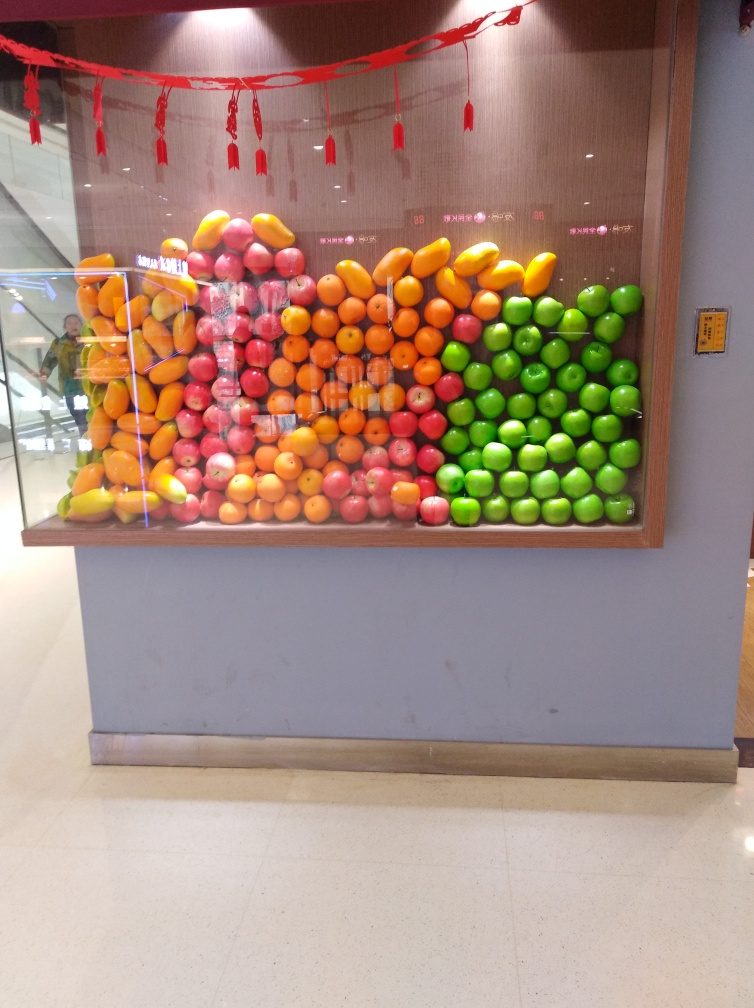Are most of the texture details on the ground in the foreground recognizable? Yes, the flooring in the foreground is well-lit and the texture details, which include a smooth, polished surface with light reflections and faint color variations, are indeed recognizable. 